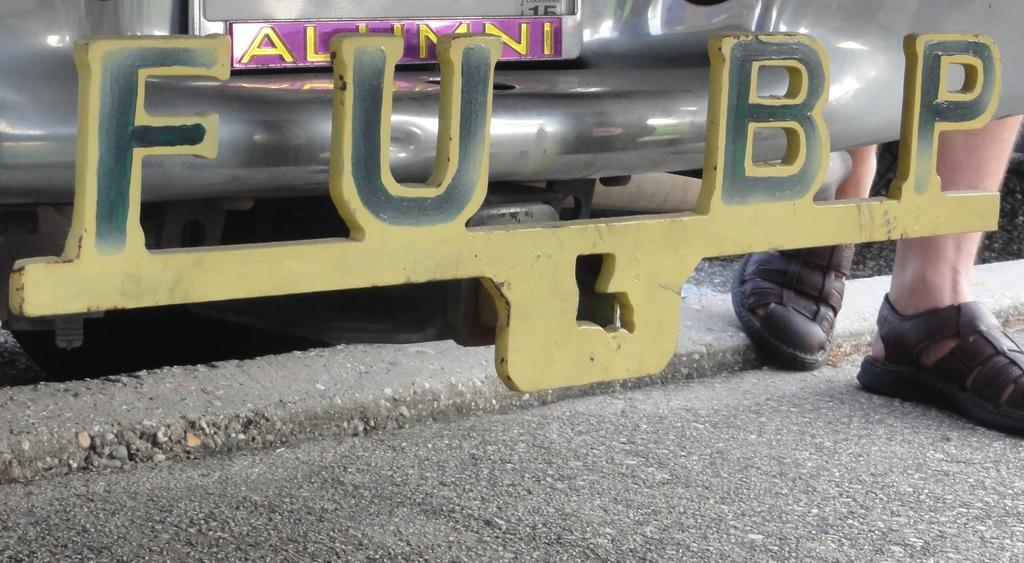What is the main subject of the image? The main subject of the image is a number plate of a car. Where is the number plate located in the image? The number plate is at the top of the image. What else can be seen in the image besides the number plate? Human legs are visible in the image. On which side of the image are the human legs located? The human legs are on the right side of the image. What type of caption is written on the number plate in the image? There is no caption written on the number plate in the image; it only contains a series of characters and numbers. How many snails can be seen crawling on the human legs in the image? There are no snails present in the image; only human legs are visible. 